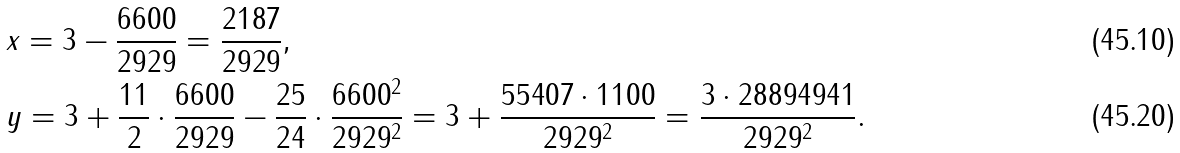<formula> <loc_0><loc_0><loc_500><loc_500>& x = 3 - \frac { 6 6 0 0 } { 2 9 2 9 } = \frac { 2 1 8 7 } { 2 9 2 9 } , \\ & y = 3 + \frac { 1 1 } { 2 } \cdot \frac { 6 6 0 0 } { 2 9 2 9 } - \frac { 2 5 } { 2 4 } \cdot \frac { 6 6 0 0 ^ { 2 } } { 2 9 2 9 ^ { 2 } } = 3 + \frac { 5 5 4 0 7 \cdot 1 1 0 0 } { 2 9 2 9 ^ { 2 } } = \frac { 3 \cdot 2 8 8 9 4 9 4 1 } { 2 9 2 9 ^ { 2 } } .</formula> 